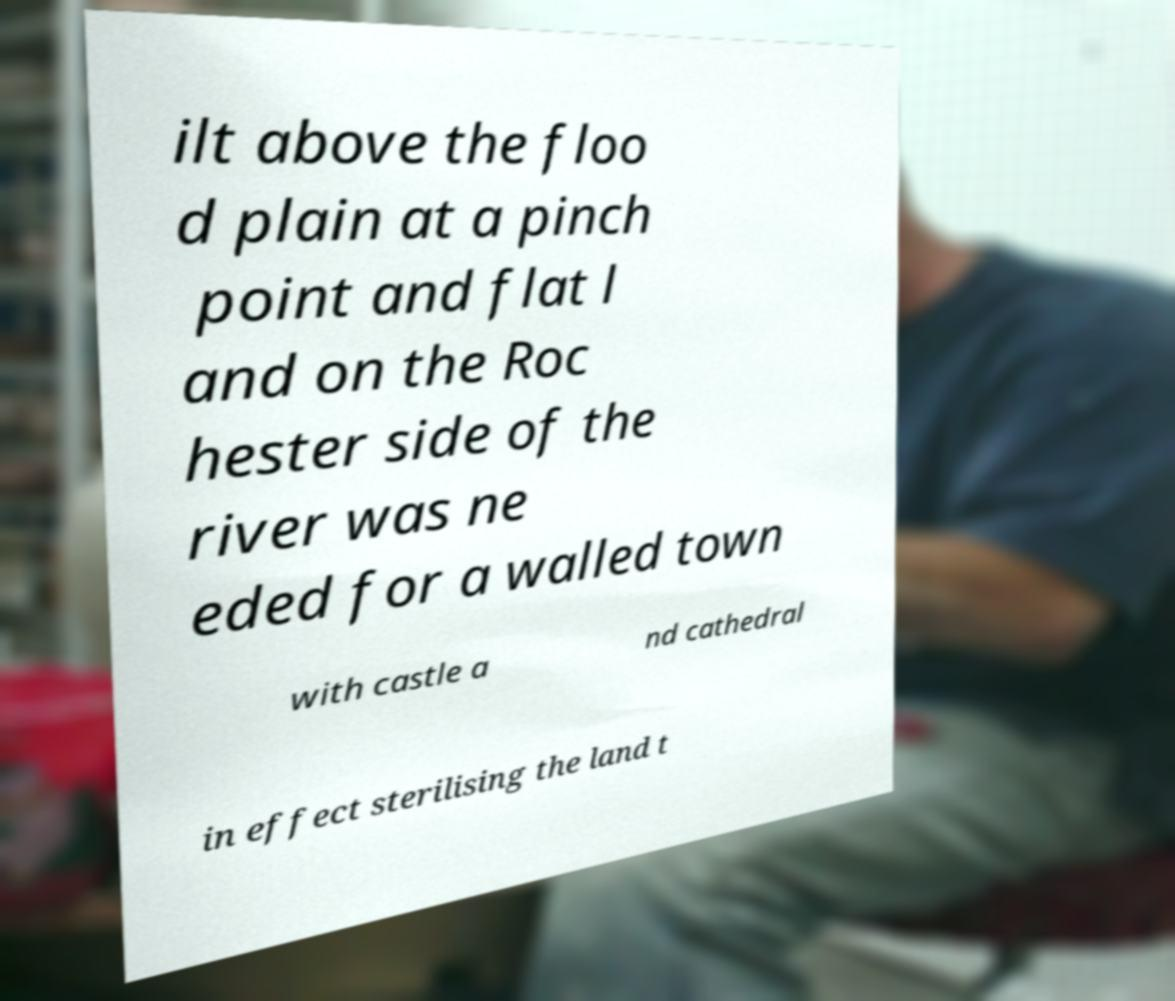Can you read and provide the text displayed in the image?This photo seems to have some interesting text. Can you extract and type it out for me? ilt above the floo d plain at a pinch point and flat l and on the Roc hester side of the river was ne eded for a walled town with castle a nd cathedral in effect sterilising the land t 